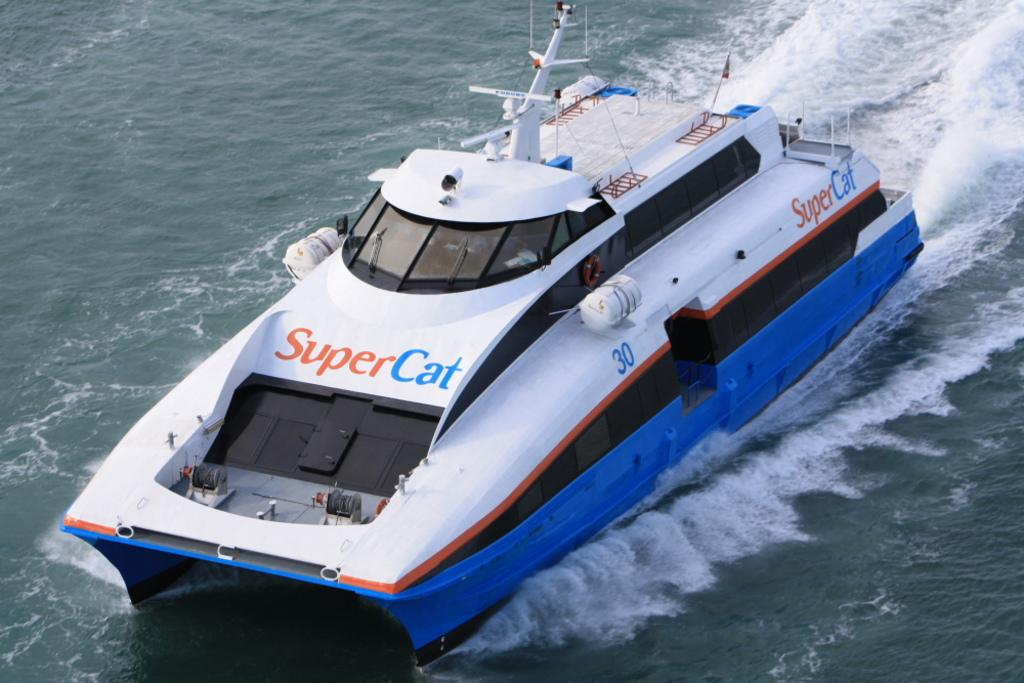What is this ferry boat's number?
Give a very brief answer. 30. 